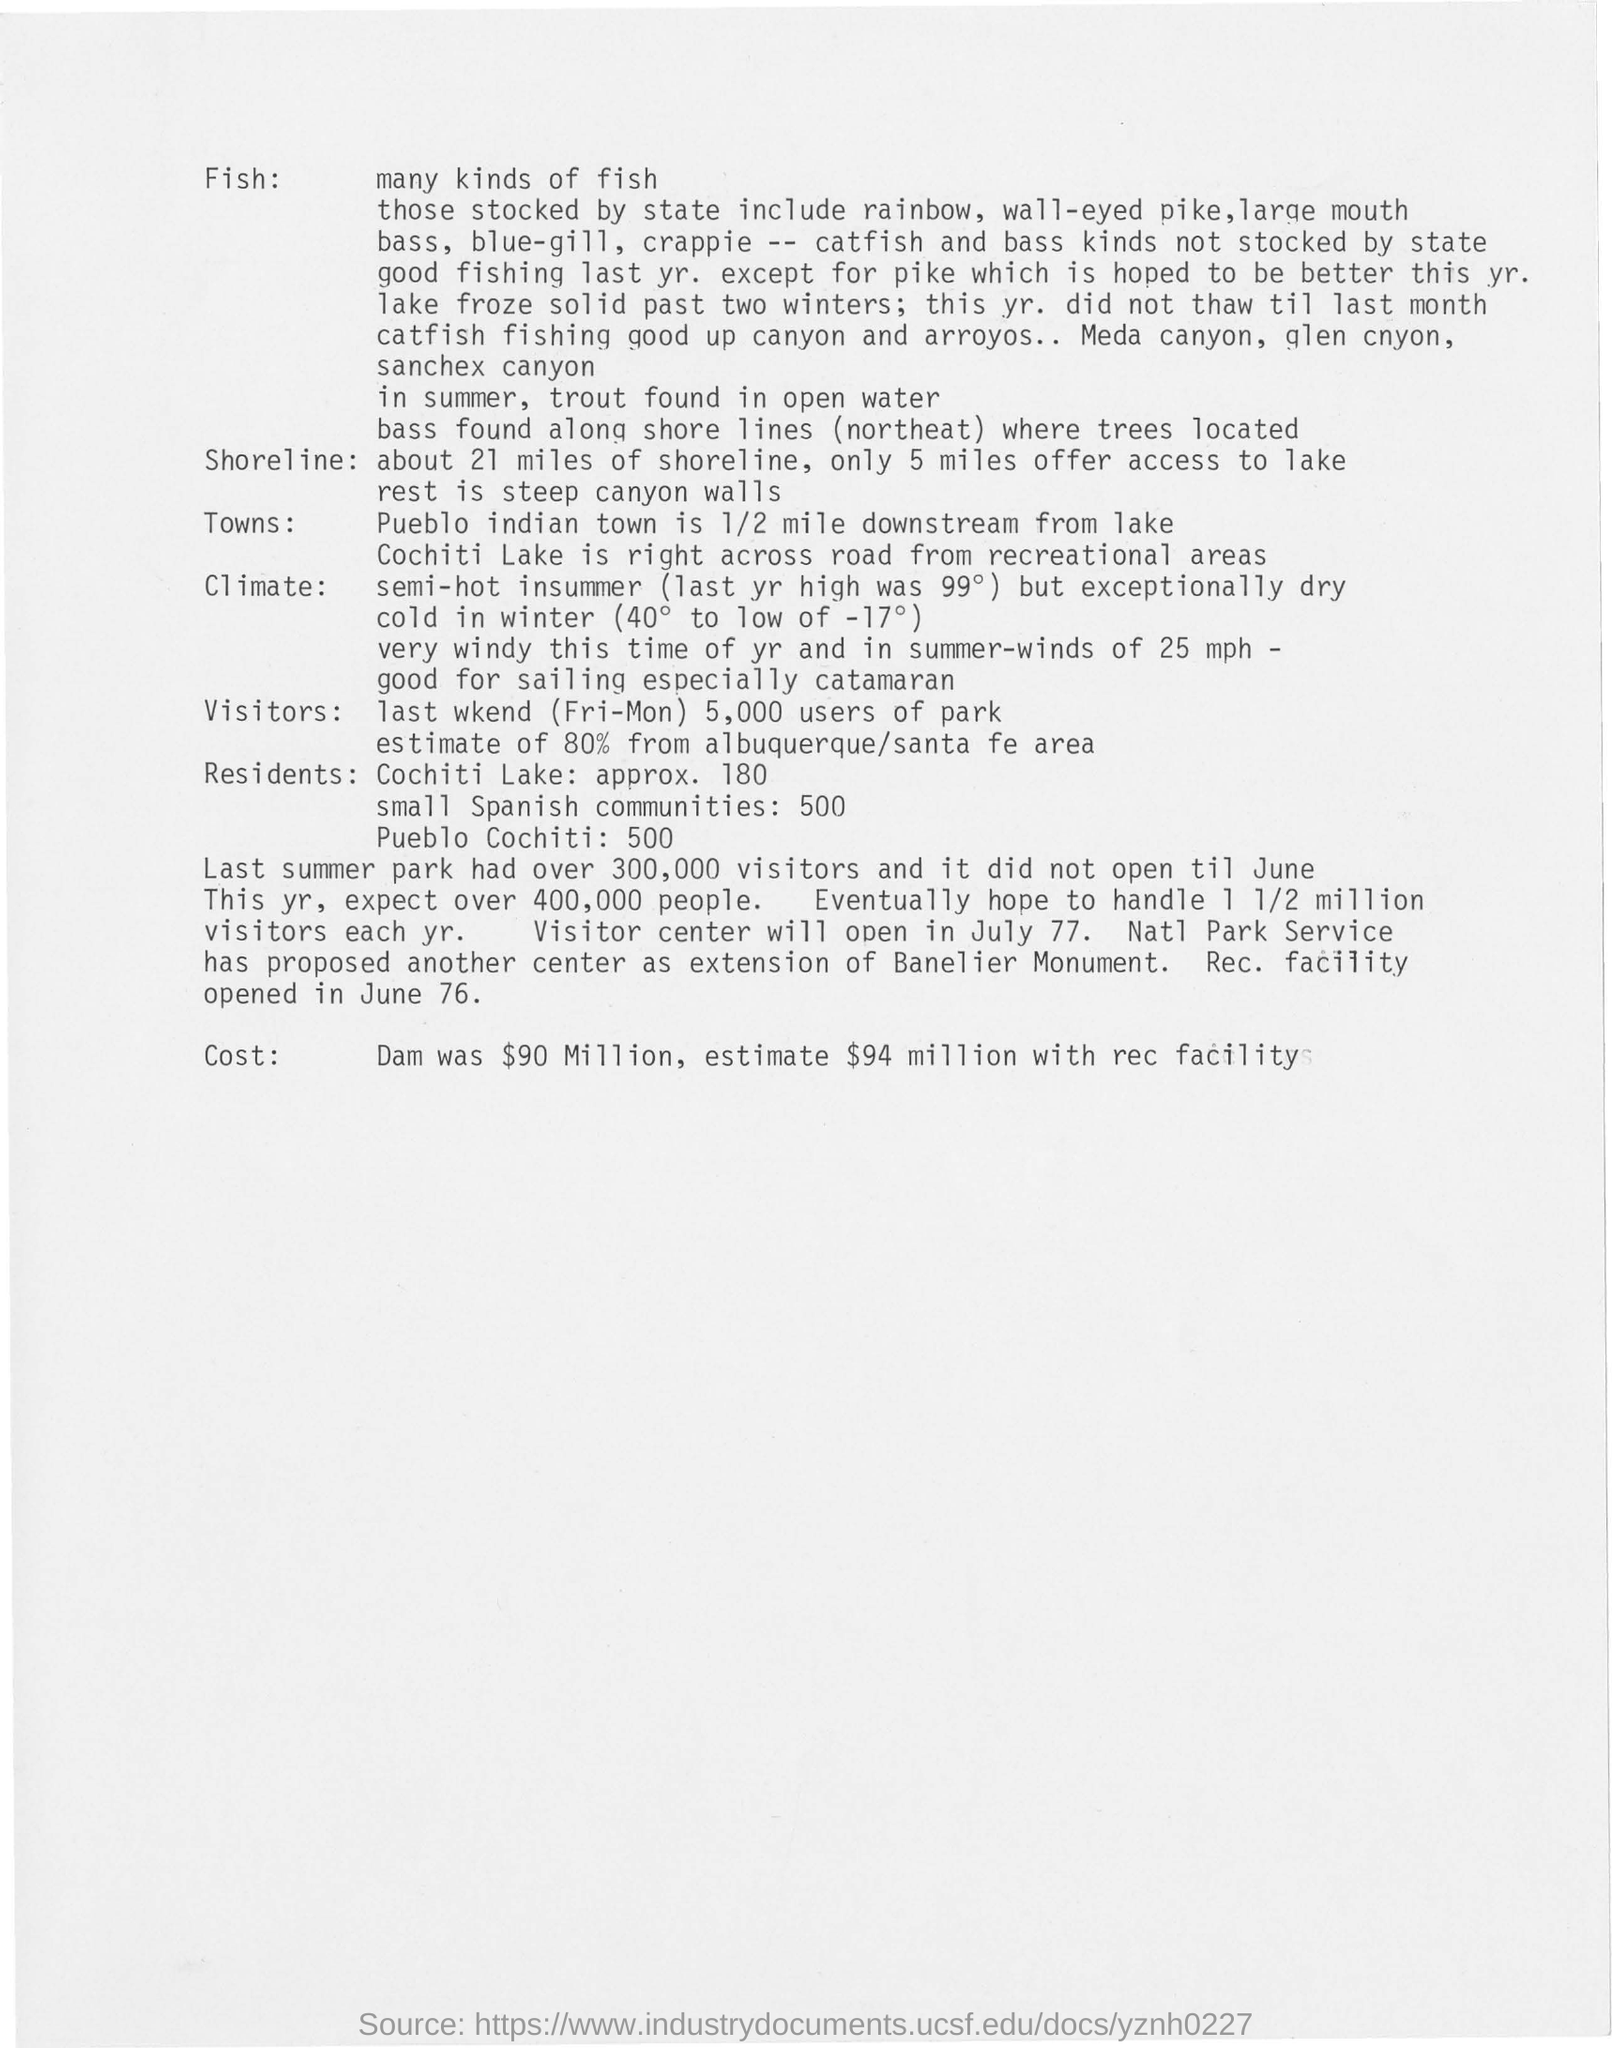List a handful of essential elements in this visual. The cost of Dam was $90 million, with an estimated additional cost of $94 million for the recreational facility. The Recreation Facility opened in June 1976. The shoreline is approximately 21 miles long. Last summer, over 300,000 visitors visited the park. 